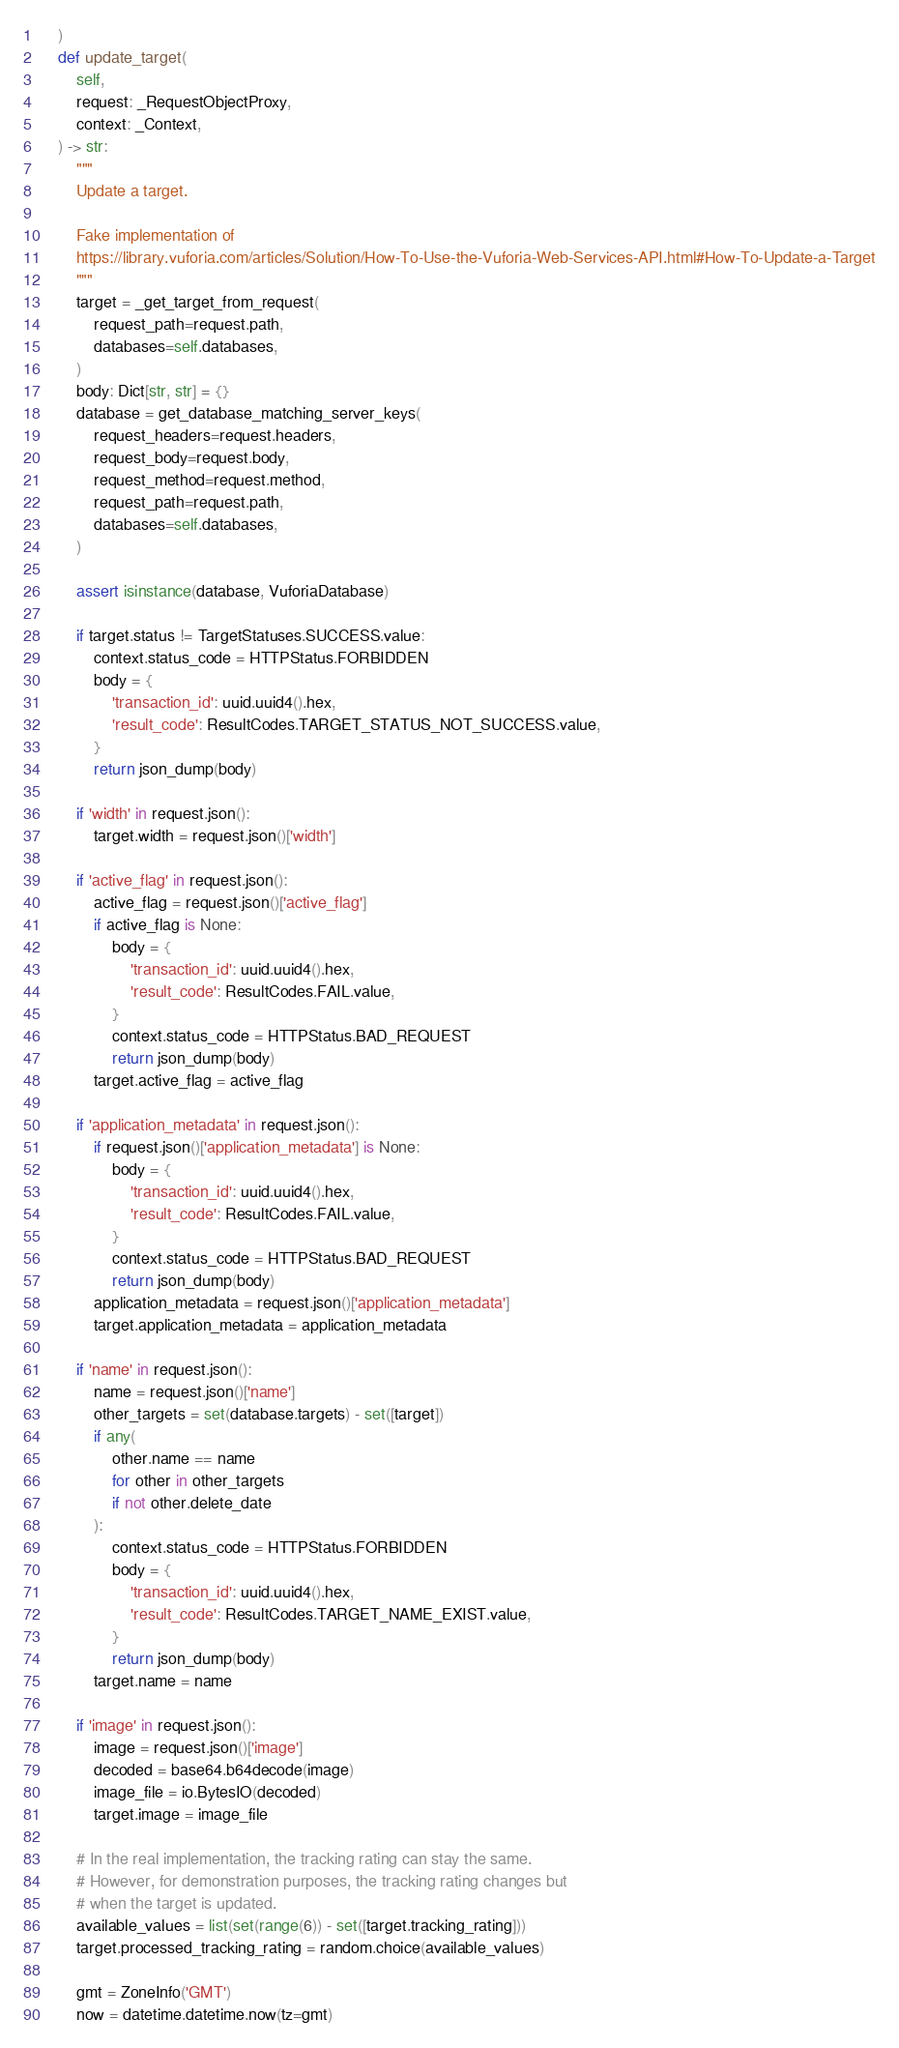Convert code to text. <code><loc_0><loc_0><loc_500><loc_500><_Python_>    )
    def update_target(
        self,
        request: _RequestObjectProxy,
        context: _Context,
    ) -> str:
        """
        Update a target.

        Fake implementation of
        https://library.vuforia.com/articles/Solution/How-To-Use-the-Vuforia-Web-Services-API.html#How-To-Update-a-Target
        """
        target = _get_target_from_request(
            request_path=request.path,
            databases=self.databases,
        )
        body: Dict[str, str] = {}
        database = get_database_matching_server_keys(
            request_headers=request.headers,
            request_body=request.body,
            request_method=request.method,
            request_path=request.path,
            databases=self.databases,
        )

        assert isinstance(database, VuforiaDatabase)

        if target.status != TargetStatuses.SUCCESS.value:
            context.status_code = HTTPStatus.FORBIDDEN
            body = {
                'transaction_id': uuid.uuid4().hex,
                'result_code': ResultCodes.TARGET_STATUS_NOT_SUCCESS.value,
            }
            return json_dump(body)

        if 'width' in request.json():
            target.width = request.json()['width']

        if 'active_flag' in request.json():
            active_flag = request.json()['active_flag']
            if active_flag is None:
                body = {
                    'transaction_id': uuid.uuid4().hex,
                    'result_code': ResultCodes.FAIL.value,
                }
                context.status_code = HTTPStatus.BAD_REQUEST
                return json_dump(body)
            target.active_flag = active_flag

        if 'application_metadata' in request.json():
            if request.json()['application_metadata'] is None:
                body = {
                    'transaction_id': uuid.uuid4().hex,
                    'result_code': ResultCodes.FAIL.value,
                }
                context.status_code = HTTPStatus.BAD_REQUEST
                return json_dump(body)
            application_metadata = request.json()['application_metadata']
            target.application_metadata = application_metadata

        if 'name' in request.json():
            name = request.json()['name']
            other_targets = set(database.targets) - set([target])
            if any(
                other.name == name
                for other in other_targets
                if not other.delete_date
            ):
                context.status_code = HTTPStatus.FORBIDDEN
                body = {
                    'transaction_id': uuid.uuid4().hex,
                    'result_code': ResultCodes.TARGET_NAME_EXIST.value,
                }
                return json_dump(body)
            target.name = name

        if 'image' in request.json():
            image = request.json()['image']
            decoded = base64.b64decode(image)
            image_file = io.BytesIO(decoded)
            target.image = image_file

        # In the real implementation, the tracking rating can stay the same.
        # However, for demonstration purposes, the tracking rating changes but
        # when the target is updated.
        available_values = list(set(range(6)) - set([target.tracking_rating]))
        target.processed_tracking_rating = random.choice(available_values)

        gmt = ZoneInfo('GMT')
        now = datetime.datetime.now(tz=gmt)</code> 